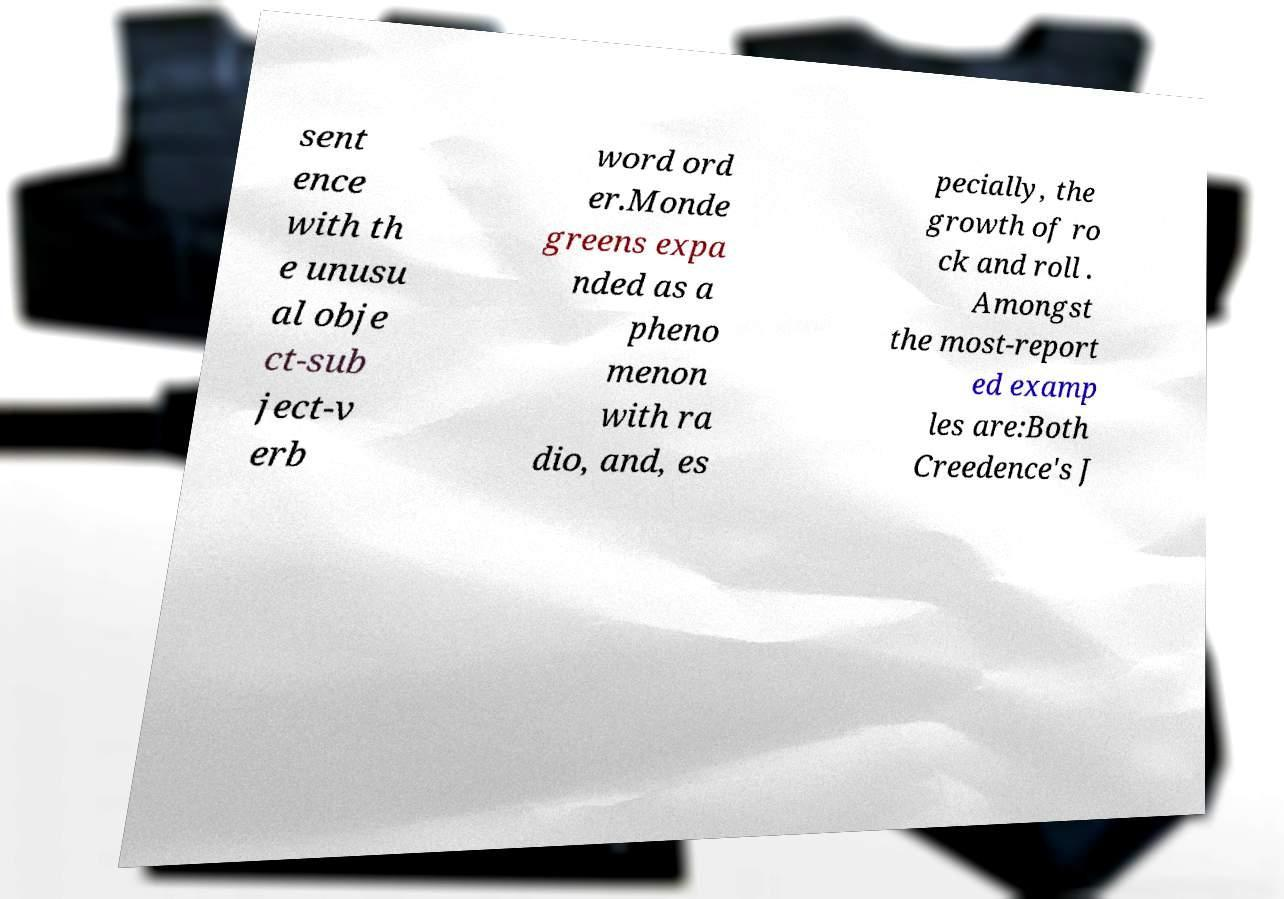I need the written content from this picture converted into text. Can you do that? sent ence with th e unusu al obje ct-sub ject-v erb word ord er.Monde greens expa nded as a pheno menon with ra dio, and, es pecially, the growth of ro ck and roll . Amongst the most-report ed examp les are:Both Creedence's J 